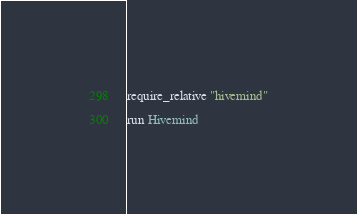Convert code to text. <code><loc_0><loc_0><loc_500><loc_500><_Ruby_>require_relative "hivemind"

run Hivemind
</code> 